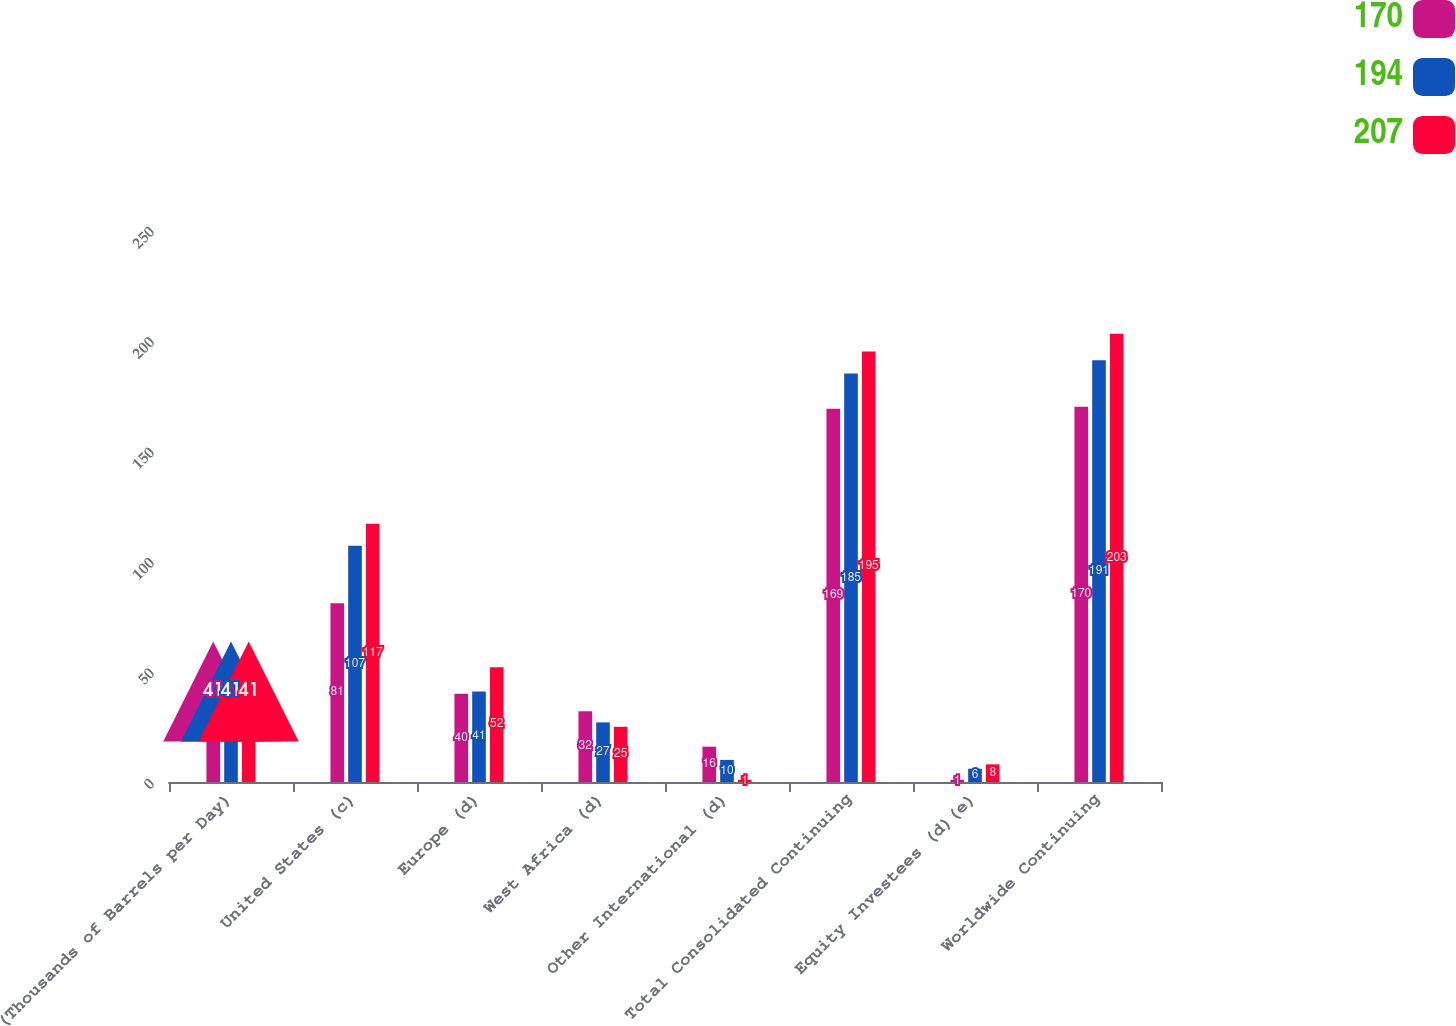Convert chart to OTSL. <chart><loc_0><loc_0><loc_500><loc_500><stacked_bar_chart><ecel><fcel>(Thousands of Barrels per Day)<fcel>United States (c)<fcel>Europe (d)<fcel>West Africa (d)<fcel>Other International (d)<fcel>Total Consolidated Continuing<fcel>Equity Investees (d)(e)<fcel>Worldwide Continuing<nl><fcel>170<fcel>41<fcel>81<fcel>40<fcel>32<fcel>16<fcel>169<fcel>1<fcel>170<nl><fcel>194<fcel>41<fcel>107<fcel>41<fcel>27<fcel>10<fcel>185<fcel>6<fcel>191<nl><fcel>207<fcel>41<fcel>117<fcel>52<fcel>25<fcel>1<fcel>195<fcel>8<fcel>203<nl></chart> 